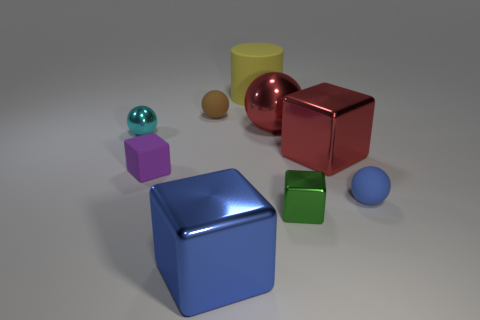There is a rubber object that is both behind the red shiny cube and in front of the large rubber thing; what size is it?
Provide a succinct answer. Small. How many other objects are the same shape as the yellow thing?
Your answer should be compact. 0. How many large rubber cylinders are on the left side of the tiny green metallic block?
Ensure brevity in your answer.  1. Are there fewer blue spheres that are to the right of the cyan thing than small rubber objects that are to the left of the red metal cube?
Your answer should be very brief. Yes. The thing behind the tiny matte sphere behind the tiny block that is behind the blue rubber thing is what shape?
Offer a terse response. Cylinder. There is a metal object that is behind the green block and to the right of the large red sphere; what shape is it?
Make the answer very short. Cube. Are there any big brown blocks that have the same material as the tiny purple block?
Your answer should be compact. No. What size is the metal cube that is the same color as the big ball?
Provide a short and direct response. Large. There is a tiny matte thing on the right side of the blue metal thing; what is its color?
Your answer should be compact. Blue. Is the shape of the yellow rubber thing the same as the tiny brown rubber thing behind the blue rubber ball?
Give a very brief answer. No. 